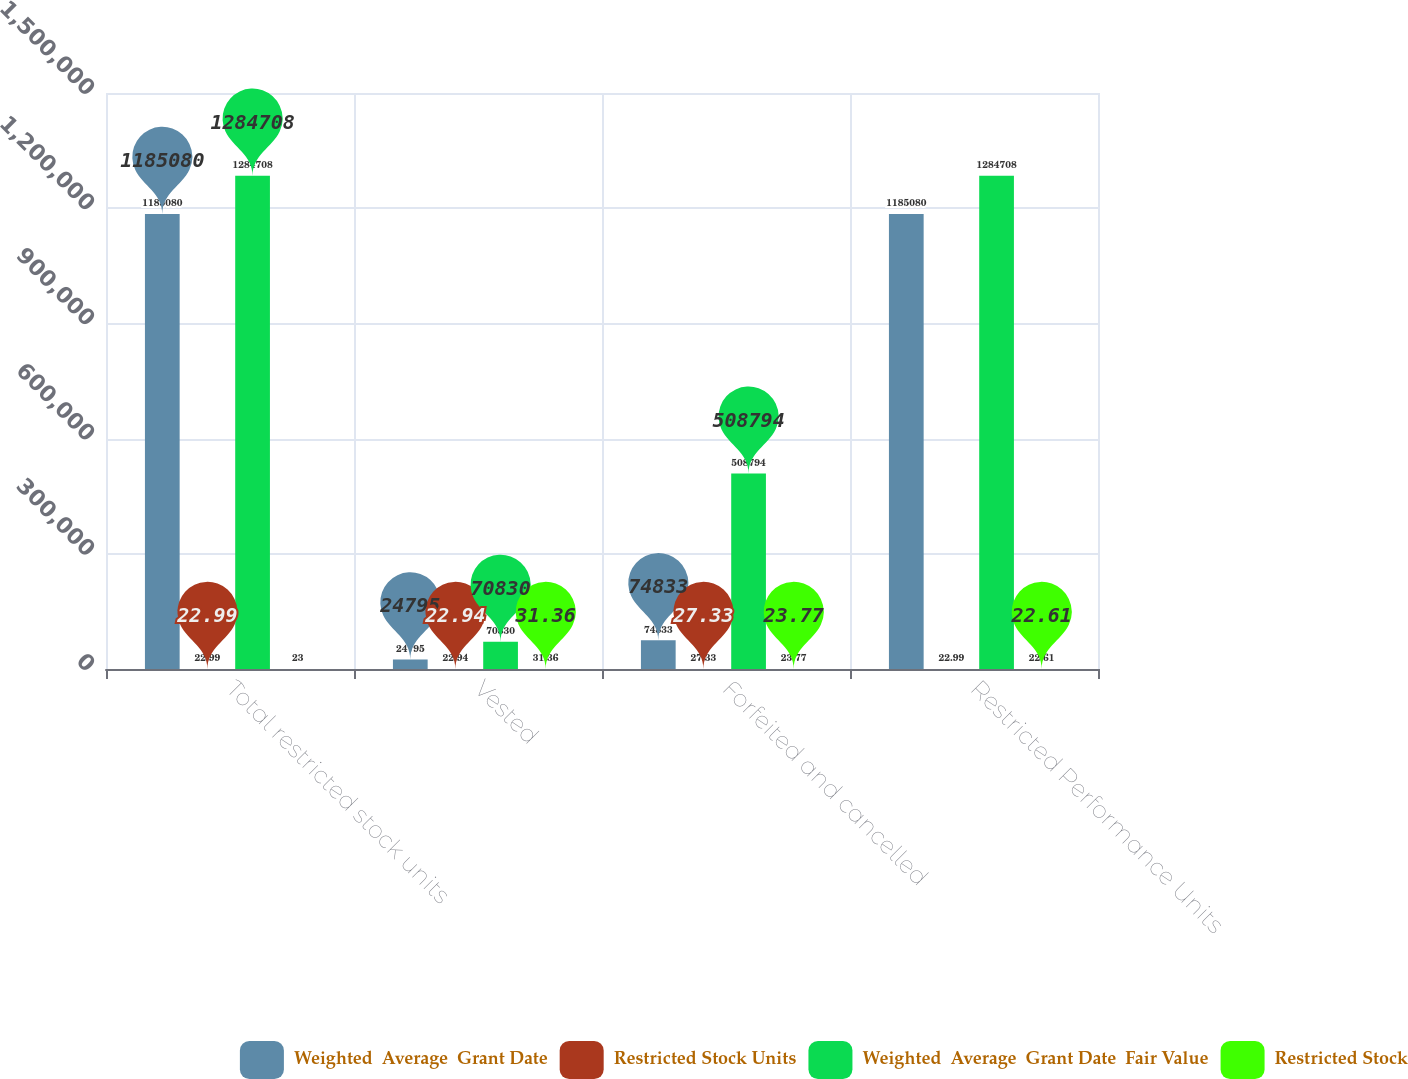<chart> <loc_0><loc_0><loc_500><loc_500><stacked_bar_chart><ecel><fcel>Total restricted stock units<fcel>Vested<fcel>Forfeited and cancelled<fcel>Restricted Performance Units<nl><fcel>Weighted  Average  Grant Date<fcel>1.18508e+06<fcel>24795<fcel>74833<fcel>1.18508e+06<nl><fcel>Restricted Stock Units<fcel>22.99<fcel>22.94<fcel>27.33<fcel>22.99<nl><fcel>Weighted  Average  Grant Date  Fair Value<fcel>1.28471e+06<fcel>70830<fcel>508794<fcel>1.28471e+06<nl><fcel>Restricted Stock<fcel>23<fcel>31.36<fcel>23.77<fcel>22.61<nl></chart> 